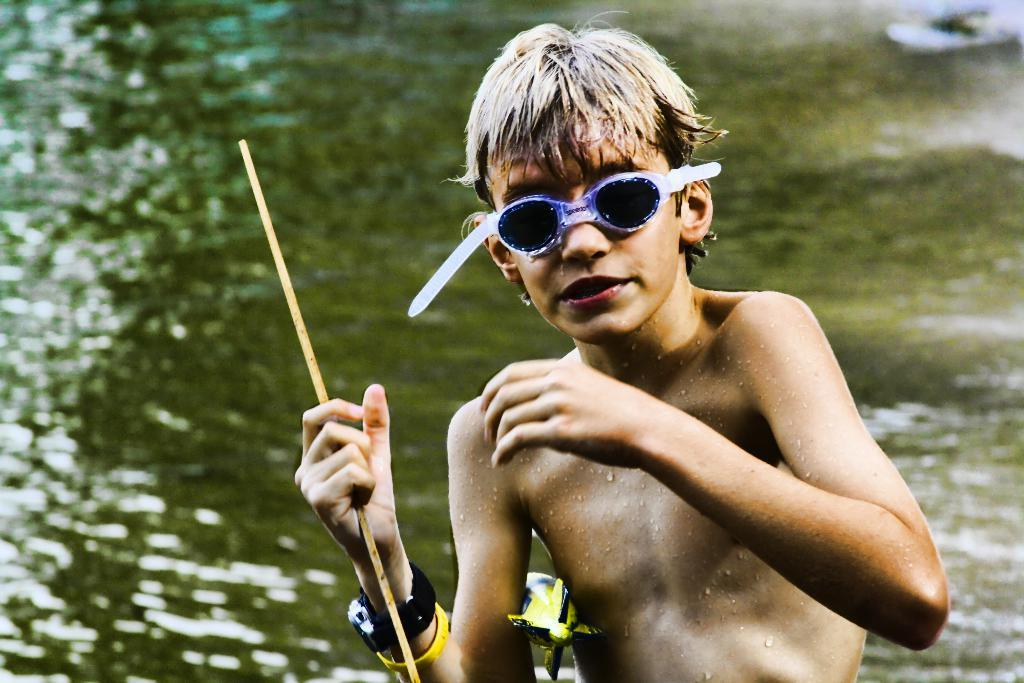Who or what is present in the image? There is a person in the image. What accessories can be seen on the person? The person is wearing spectacles and a watch. What can be seen in the background of the image? There is water visible in the background of the image. What type of rice is being cooked on the stove in the image? There is no stove or rice present in the image; it only features a person wearing spectacles and a watch, with water visible in the background. 